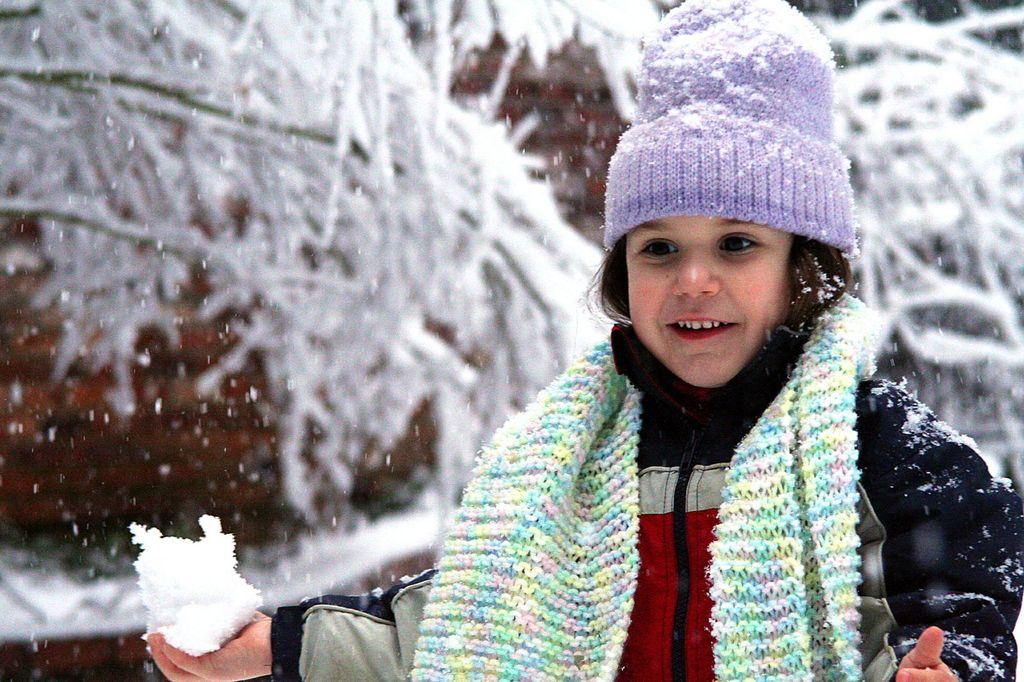Who is the main subject in the image? There is a girl in the image. What is the girl holding in the image? The girl is holding snow in the image. What clothing items is the girl wearing? The girl is wearing a jacket, a cap, and a scarf in the image. What can be seen in the background of the image? There are trees in the background of the image. What is the condition of the trees in the image? The trees are fully covered with snow in the image. What page is the girl reading in the image? There is no page or book present in the image; the girl is holding snow. What type of camp can be seen in the background of the image? There is no camp present in the image; the background features trees covered in snow. 